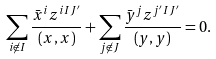<formula> <loc_0><loc_0><loc_500><loc_500>\sum _ { i \not \in I } \frac { \bar { x } ^ { i } z ^ { i I J ^ { \prime } } } { ( x , x ) } + \sum _ { j \not \in J } \frac { \bar { y } ^ { j } z ^ { j ^ { \prime } I J ^ { \prime } } } { ( y , y ) } = 0 .</formula> 